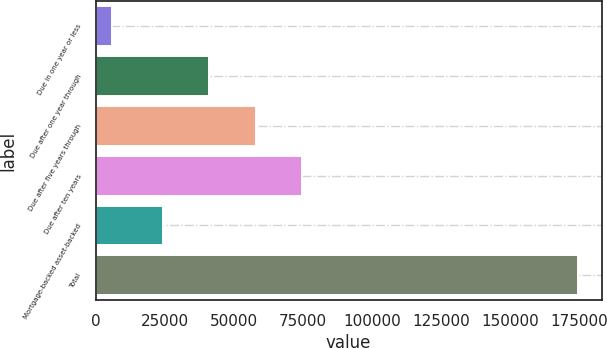Convert chart. <chart><loc_0><loc_0><loc_500><loc_500><bar_chart><fcel>Due in one year or less<fcel>Due after one year through<fcel>Due after five years through<fcel>Due after ten years<fcel>Mortgage-backed asset-backed<fcel>Total<nl><fcel>6023<fcel>41165<fcel>58011<fcel>74857<fcel>24319<fcel>174483<nl></chart> 